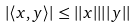<formula> <loc_0><loc_0><loc_500><loc_500>| \langle x , y \rangle | \leq | | x | | | | y | |</formula> 